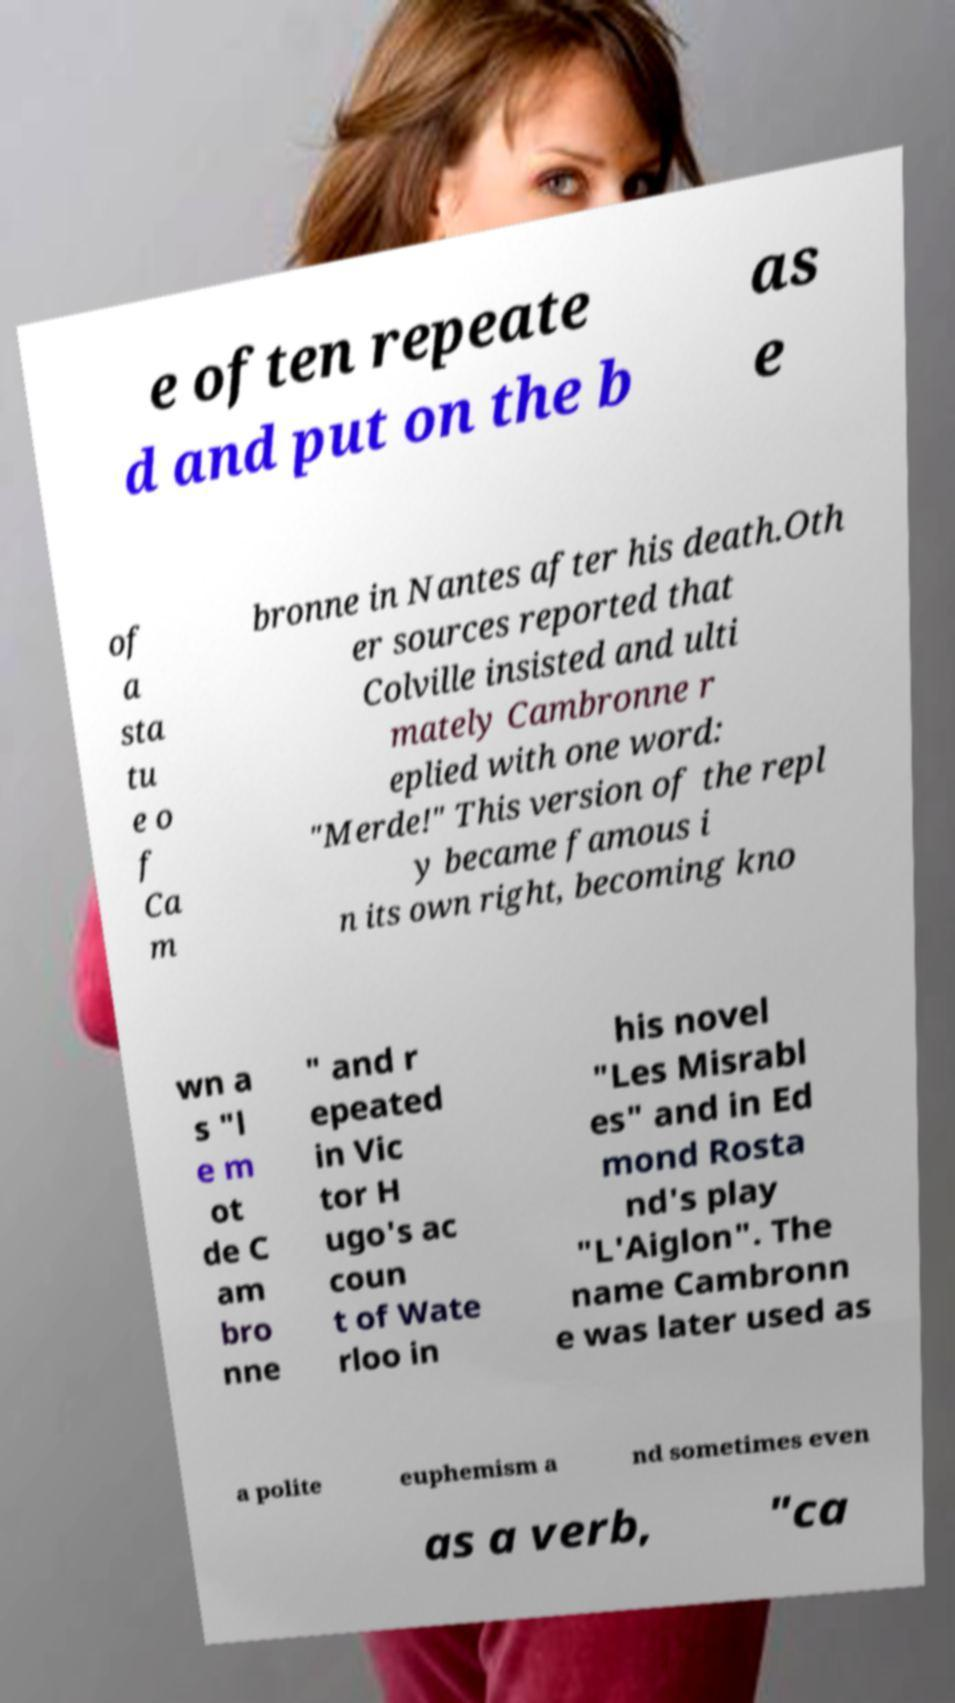I need the written content from this picture converted into text. Can you do that? e often repeate d and put on the b as e of a sta tu e o f Ca m bronne in Nantes after his death.Oth er sources reported that Colville insisted and ulti mately Cambronne r eplied with one word: "Merde!" This version of the repl y became famous i n its own right, becoming kno wn a s "l e m ot de C am bro nne " and r epeated in Vic tor H ugo's ac coun t of Wate rloo in his novel "Les Misrabl es" and in Ed mond Rosta nd's play "L'Aiglon". The name Cambronn e was later used as a polite euphemism a nd sometimes even as a verb, "ca 